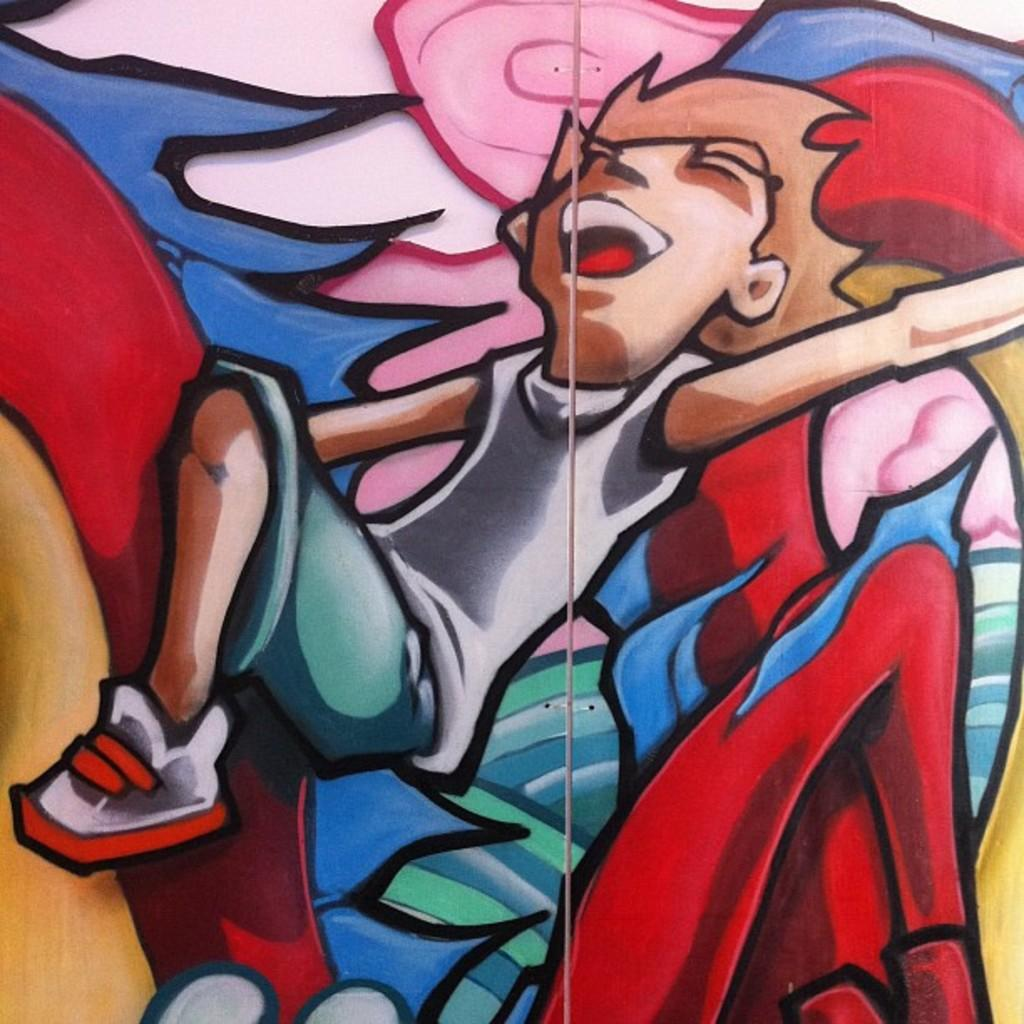What type of images are present in the image? The image consists of cartoons. Can you describe the main subject of the image? There is a painting of a boy in the image. What is the boy wearing in the image? The boy is wearing a white shirt. What type of current can be seen flowing through the boy's shirt in the image? There is no current present in the image; it is a painting of a boy wearing a white shirt. How many straws are visible in the image? There are no straws present in the image. 